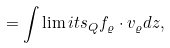<formula> <loc_0><loc_0><loc_500><loc_500>= \int \lim i t s _ { Q } f _ { \varrho } \cdot v _ { \varrho } d z ,</formula> 